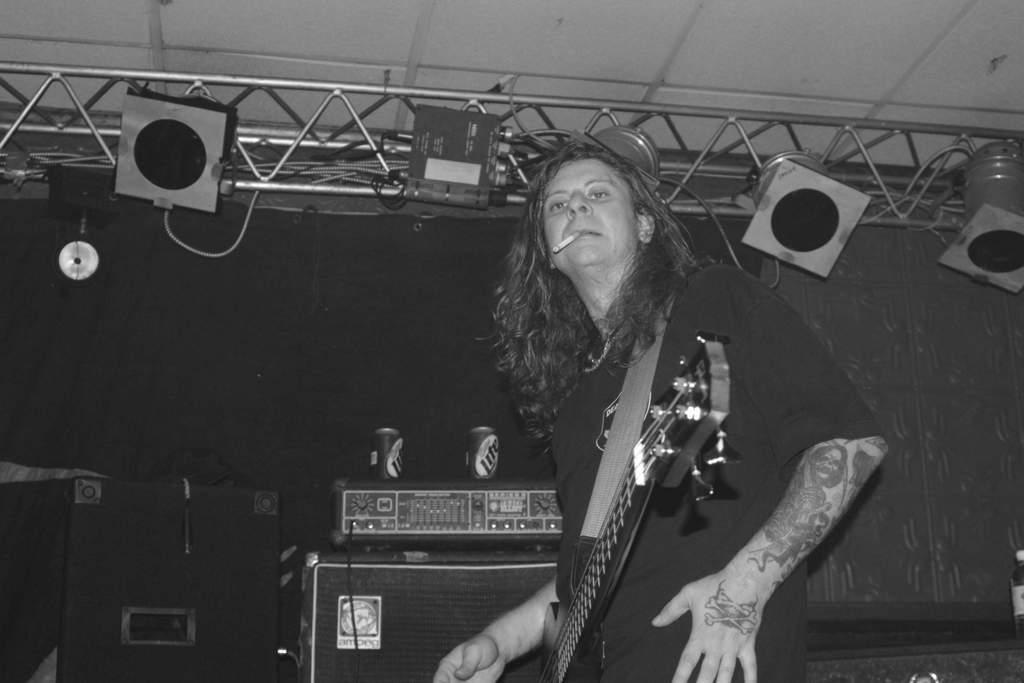How would you summarize this image in a sentence or two? a person is standing and holding a guitar. there is a cigar in his mouth. behind him there are speakers. 